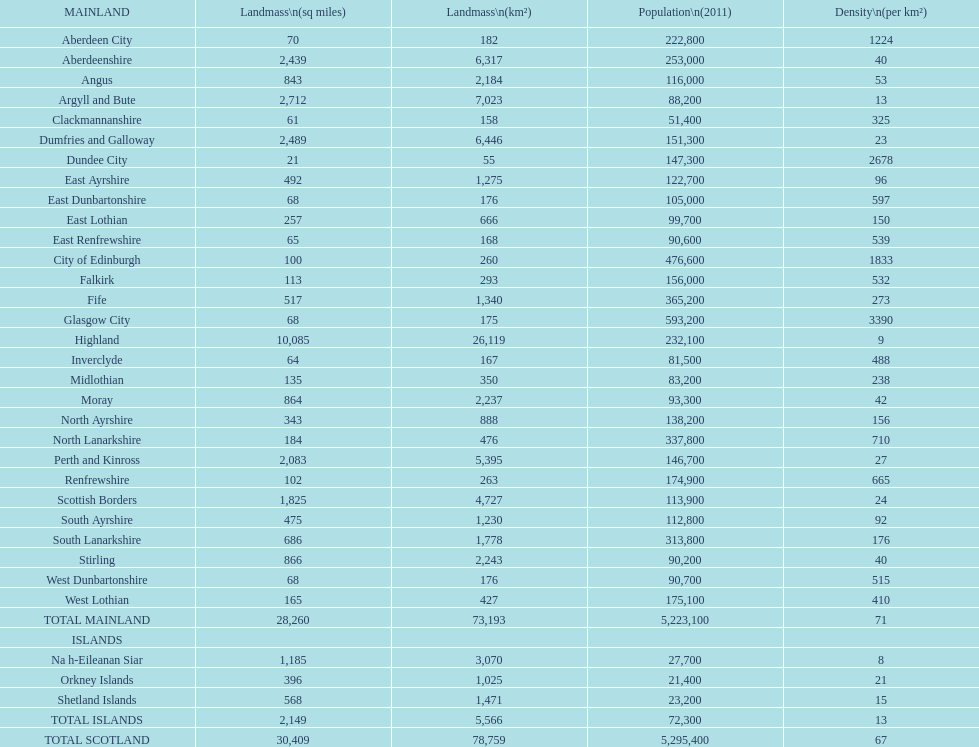Which mainland has the least population? Clackmannanshire. 